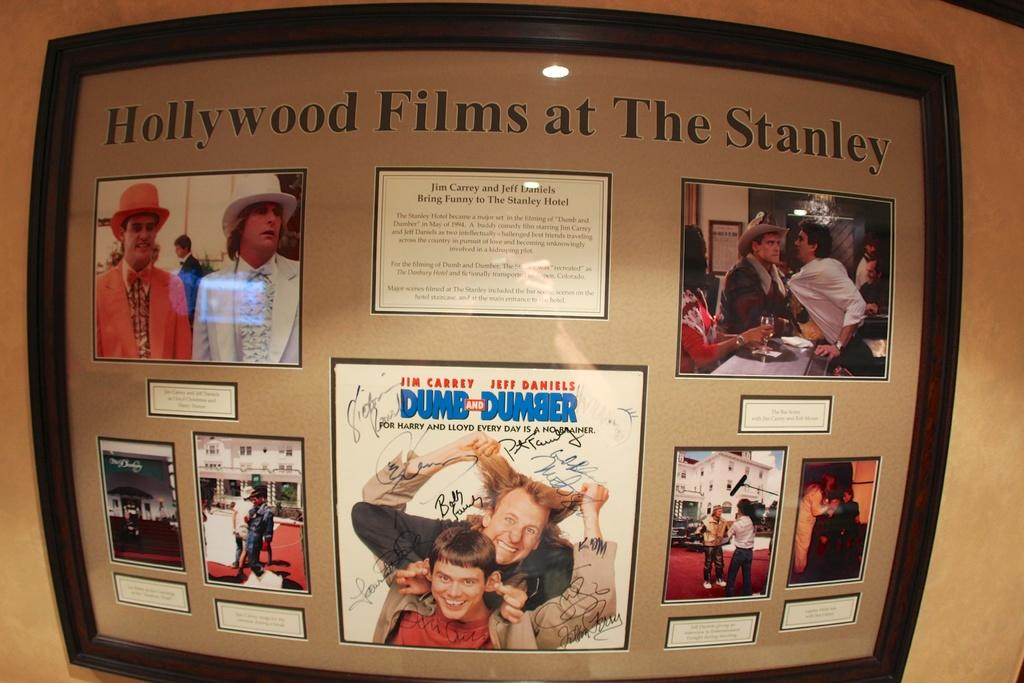<image>
Relay a brief, clear account of the picture shown. A framed set of images from the movie Dumb and Dumber is titled Hollywood Films at The Stanley. 